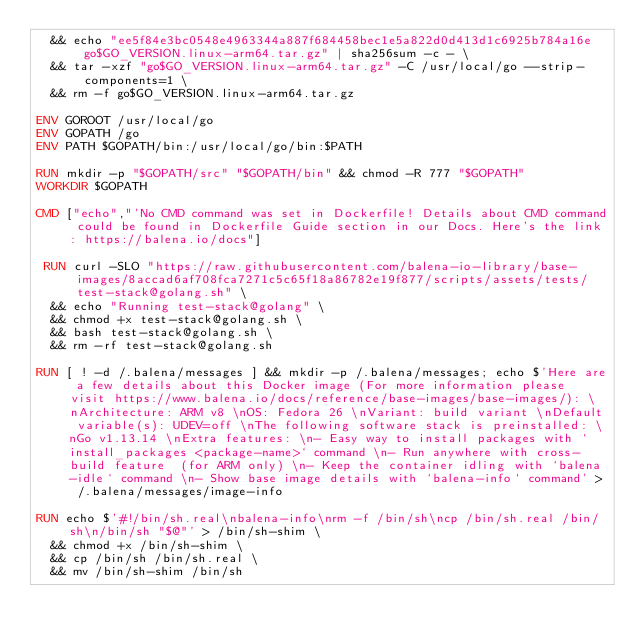<code> <loc_0><loc_0><loc_500><loc_500><_Dockerfile_>	&& echo "ee5f84e3bc0548e4963344a887f684458bec1e5a822d0d413d1c6925b784a16e  go$GO_VERSION.linux-arm64.tar.gz" | sha256sum -c - \
	&& tar -xzf "go$GO_VERSION.linux-arm64.tar.gz" -C /usr/local/go --strip-components=1 \
	&& rm -f go$GO_VERSION.linux-arm64.tar.gz

ENV GOROOT /usr/local/go
ENV GOPATH /go
ENV PATH $GOPATH/bin:/usr/local/go/bin:$PATH

RUN mkdir -p "$GOPATH/src" "$GOPATH/bin" && chmod -R 777 "$GOPATH"
WORKDIR $GOPATH

CMD ["echo","'No CMD command was set in Dockerfile! Details about CMD command could be found in Dockerfile Guide section in our Docs. Here's the link: https://balena.io/docs"]

 RUN curl -SLO "https://raw.githubusercontent.com/balena-io-library/base-images/8accad6af708fca7271c5c65f18a86782e19f877/scripts/assets/tests/test-stack@golang.sh" \
  && echo "Running test-stack@golang" \
  && chmod +x test-stack@golang.sh \
  && bash test-stack@golang.sh \
  && rm -rf test-stack@golang.sh 

RUN [ ! -d /.balena/messages ] && mkdir -p /.balena/messages; echo $'Here are a few details about this Docker image (For more information please visit https://www.balena.io/docs/reference/base-images/base-images/): \nArchitecture: ARM v8 \nOS: Fedora 26 \nVariant: build variant \nDefault variable(s): UDEV=off \nThe following software stack is preinstalled: \nGo v1.13.14 \nExtra features: \n- Easy way to install packages with `install_packages <package-name>` command \n- Run anywhere with cross-build feature  (for ARM only) \n- Keep the container idling with `balena-idle` command \n- Show base image details with `balena-info` command' > /.balena/messages/image-info

RUN echo $'#!/bin/sh.real\nbalena-info\nrm -f /bin/sh\ncp /bin/sh.real /bin/sh\n/bin/sh "$@"' > /bin/sh-shim \
	&& chmod +x /bin/sh-shim \
	&& cp /bin/sh /bin/sh.real \
	&& mv /bin/sh-shim /bin/sh</code> 